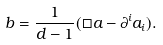Convert formula to latex. <formula><loc_0><loc_0><loc_500><loc_500>b = \frac { 1 } { d - 1 } ( \Box a - \partial ^ { i } a _ { i } ) .</formula> 